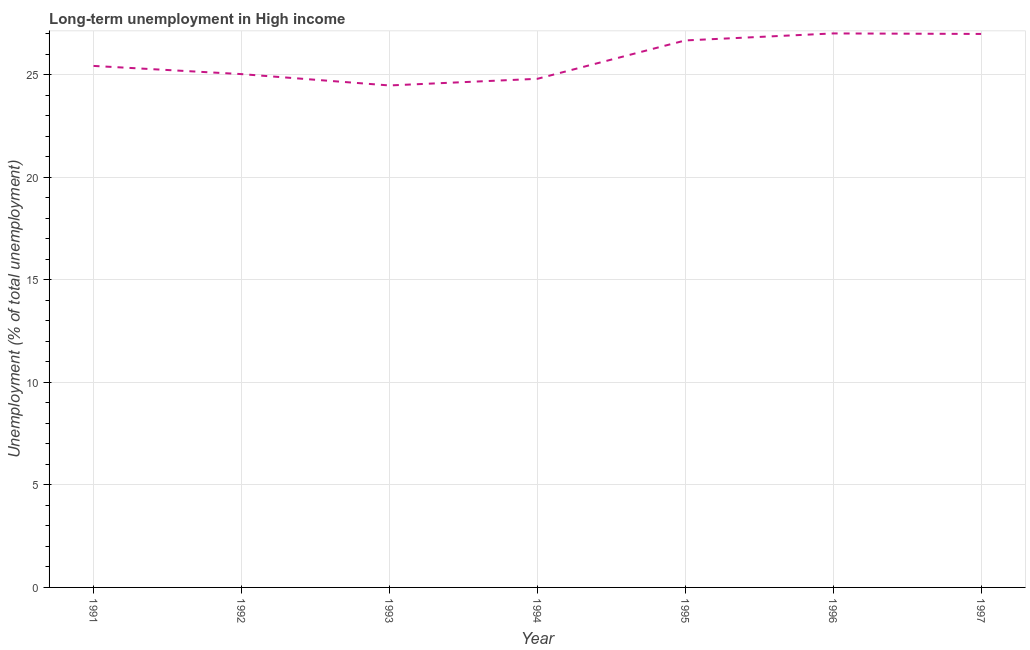What is the long-term unemployment in 1996?
Keep it short and to the point. 27.01. Across all years, what is the maximum long-term unemployment?
Provide a succinct answer. 27.01. Across all years, what is the minimum long-term unemployment?
Ensure brevity in your answer.  24.47. What is the sum of the long-term unemployment?
Your answer should be compact. 180.36. What is the difference between the long-term unemployment in 1992 and 1997?
Make the answer very short. -1.96. What is the average long-term unemployment per year?
Provide a short and direct response. 25.77. What is the median long-term unemployment?
Your response must be concise. 25.42. In how many years, is the long-term unemployment greater than 16 %?
Offer a terse response. 7. Do a majority of the years between 1992 and 1991 (inclusive) have long-term unemployment greater than 12 %?
Offer a very short reply. No. What is the ratio of the long-term unemployment in 1993 to that in 1995?
Your response must be concise. 0.92. Is the long-term unemployment in 1992 less than that in 1994?
Give a very brief answer. No. What is the difference between the highest and the second highest long-term unemployment?
Ensure brevity in your answer.  0.03. What is the difference between the highest and the lowest long-term unemployment?
Make the answer very short. 2.54. In how many years, is the long-term unemployment greater than the average long-term unemployment taken over all years?
Keep it short and to the point. 3. What is the difference between two consecutive major ticks on the Y-axis?
Provide a succinct answer. 5. What is the title of the graph?
Your answer should be compact. Long-term unemployment in High income. What is the label or title of the Y-axis?
Offer a very short reply. Unemployment (% of total unemployment). What is the Unemployment (% of total unemployment) of 1991?
Provide a succinct answer. 25.42. What is the Unemployment (% of total unemployment) of 1992?
Your answer should be compact. 25.02. What is the Unemployment (% of total unemployment) in 1993?
Offer a terse response. 24.47. What is the Unemployment (% of total unemployment) of 1994?
Offer a very short reply. 24.79. What is the Unemployment (% of total unemployment) of 1995?
Ensure brevity in your answer.  26.66. What is the Unemployment (% of total unemployment) of 1996?
Keep it short and to the point. 27.01. What is the Unemployment (% of total unemployment) of 1997?
Provide a succinct answer. 26.98. What is the difference between the Unemployment (% of total unemployment) in 1991 and 1992?
Provide a short and direct response. 0.4. What is the difference between the Unemployment (% of total unemployment) in 1991 and 1993?
Make the answer very short. 0.95. What is the difference between the Unemployment (% of total unemployment) in 1991 and 1994?
Your answer should be very brief. 0.63. What is the difference between the Unemployment (% of total unemployment) in 1991 and 1995?
Ensure brevity in your answer.  -1.24. What is the difference between the Unemployment (% of total unemployment) in 1991 and 1996?
Your answer should be very brief. -1.58. What is the difference between the Unemployment (% of total unemployment) in 1991 and 1997?
Offer a very short reply. -1.56. What is the difference between the Unemployment (% of total unemployment) in 1992 and 1993?
Give a very brief answer. 0.55. What is the difference between the Unemployment (% of total unemployment) in 1992 and 1994?
Your answer should be very brief. 0.23. What is the difference between the Unemployment (% of total unemployment) in 1992 and 1995?
Make the answer very short. -1.64. What is the difference between the Unemployment (% of total unemployment) in 1992 and 1996?
Your answer should be compact. -1.98. What is the difference between the Unemployment (% of total unemployment) in 1992 and 1997?
Provide a succinct answer. -1.96. What is the difference between the Unemployment (% of total unemployment) in 1993 and 1994?
Your response must be concise. -0.32. What is the difference between the Unemployment (% of total unemployment) in 1993 and 1995?
Give a very brief answer. -2.19. What is the difference between the Unemployment (% of total unemployment) in 1993 and 1996?
Provide a short and direct response. -2.54. What is the difference between the Unemployment (% of total unemployment) in 1993 and 1997?
Provide a succinct answer. -2.51. What is the difference between the Unemployment (% of total unemployment) in 1994 and 1995?
Offer a terse response. -1.87. What is the difference between the Unemployment (% of total unemployment) in 1994 and 1996?
Keep it short and to the point. -2.21. What is the difference between the Unemployment (% of total unemployment) in 1994 and 1997?
Make the answer very short. -2.19. What is the difference between the Unemployment (% of total unemployment) in 1995 and 1996?
Offer a very short reply. -0.34. What is the difference between the Unemployment (% of total unemployment) in 1995 and 1997?
Your answer should be very brief. -0.32. What is the difference between the Unemployment (% of total unemployment) in 1996 and 1997?
Your answer should be compact. 0.03. What is the ratio of the Unemployment (% of total unemployment) in 1991 to that in 1992?
Provide a succinct answer. 1.02. What is the ratio of the Unemployment (% of total unemployment) in 1991 to that in 1993?
Keep it short and to the point. 1.04. What is the ratio of the Unemployment (% of total unemployment) in 1991 to that in 1995?
Your answer should be compact. 0.95. What is the ratio of the Unemployment (% of total unemployment) in 1991 to that in 1996?
Ensure brevity in your answer.  0.94. What is the ratio of the Unemployment (% of total unemployment) in 1991 to that in 1997?
Ensure brevity in your answer.  0.94. What is the ratio of the Unemployment (% of total unemployment) in 1992 to that in 1994?
Provide a succinct answer. 1.01. What is the ratio of the Unemployment (% of total unemployment) in 1992 to that in 1995?
Give a very brief answer. 0.94. What is the ratio of the Unemployment (% of total unemployment) in 1992 to that in 1996?
Ensure brevity in your answer.  0.93. What is the ratio of the Unemployment (% of total unemployment) in 1992 to that in 1997?
Give a very brief answer. 0.93. What is the ratio of the Unemployment (% of total unemployment) in 1993 to that in 1994?
Your answer should be very brief. 0.99. What is the ratio of the Unemployment (% of total unemployment) in 1993 to that in 1995?
Provide a short and direct response. 0.92. What is the ratio of the Unemployment (% of total unemployment) in 1993 to that in 1996?
Give a very brief answer. 0.91. What is the ratio of the Unemployment (% of total unemployment) in 1993 to that in 1997?
Provide a succinct answer. 0.91. What is the ratio of the Unemployment (% of total unemployment) in 1994 to that in 1996?
Provide a succinct answer. 0.92. What is the ratio of the Unemployment (% of total unemployment) in 1994 to that in 1997?
Provide a short and direct response. 0.92. What is the ratio of the Unemployment (% of total unemployment) in 1995 to that in 1997?
Your answer should be very brief. 0.99. What is the ratio of the Unemployment (% of total unemployment) in 1996 to that in 1997?
Keep it short and to the point. 1. 